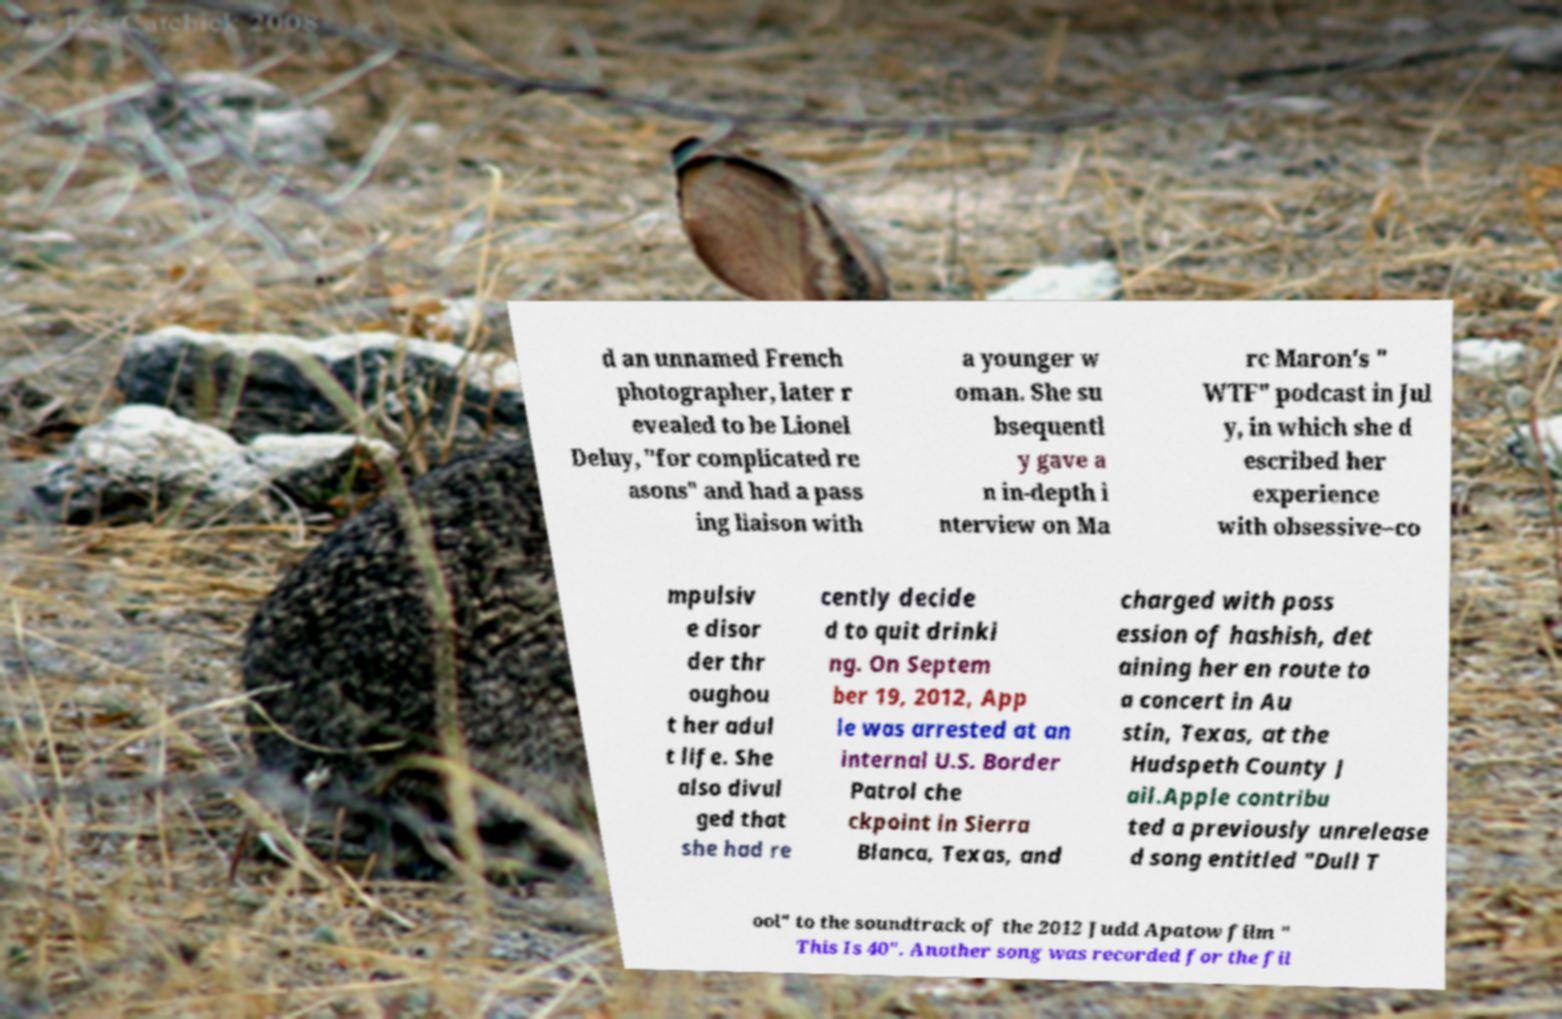I need the written content from this picture converted into text. Can you do that? d an unnamed French photographer, later r evealed to be Lionel Deluy, "for complicated re asons" and had a pass ing liaison with a younger w oman. She su bsequentl y gave a n in-depth i nterview on Ma rc Maron's " WTF" podcast in Jul y, in which she d escribed her experience with obsessive–co mpulsiv e disor der thr oughou t her adul t life. She also divul ged that she had re cently decide d to quit drinki ng. On Septem ber 19, 2012, App le was arrested at an internal U.S. Border Patrol che ckpoint in Sierra Blanca, Texas, and charged with poss ession of hashish, det aining her en route to a concert in Au stin, Texas, at the Hudspeth County J ail.Apple contribu ted a previously unrelease d song entitled "Dull T ool" to the soundtrack of the 2012 Judd Apatow film " This Is 40". Another song was recorded for the fil 